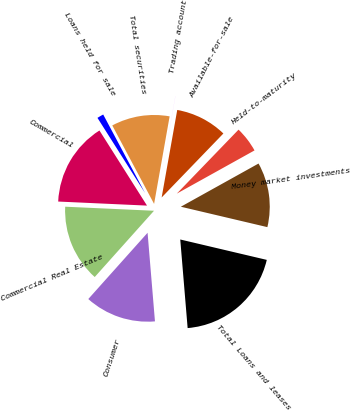Convert chart to OTSL. <chart><loc_0><loc_0><loc_500><loc_500><pie_chart><fcel>Money market investments<fcel>Held-to-maturity<fcel>Available-for-sale<fcel>Trading account<fcel>Total securities<fcel>Loans held for sale<fcel>Commercial<fcel>Commercial Real Estate<fcel>Consumer<fcel>Total Loans and leases<nl><fcel>11.76%<fcel>4.71%<fcel>9.41%<fcel>0.01%<fcel>10.59%<fcel>1.19%<fcel>15.29%<fcel>14.11%<fcel>12.94%<fcel>19.99%<nl></chart> 